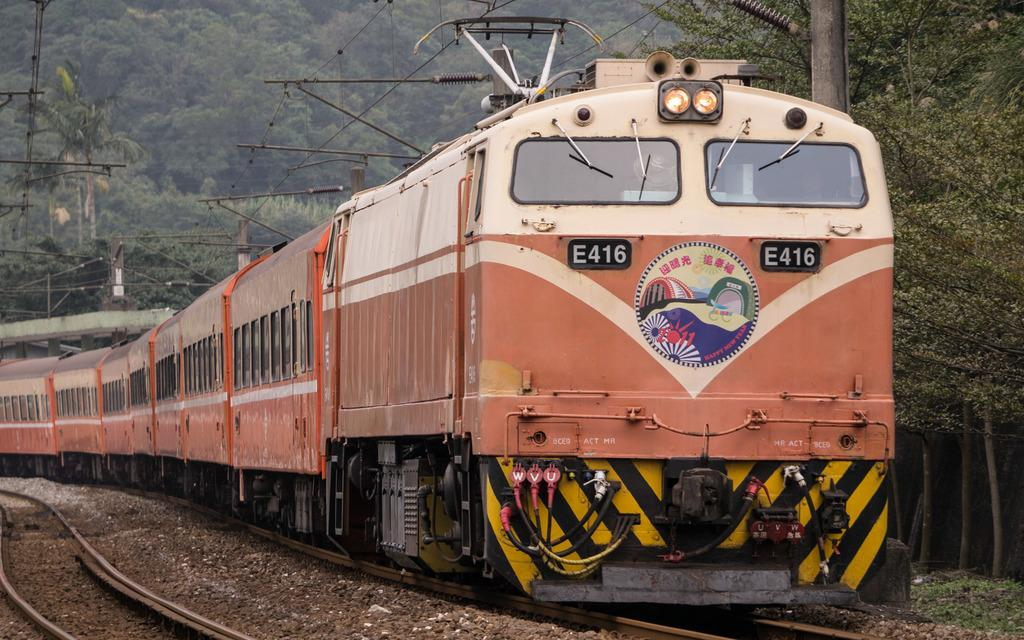<image>
Provide a brief description of the given image. Train E416 has a 2011 Happy New Year plate on front. 